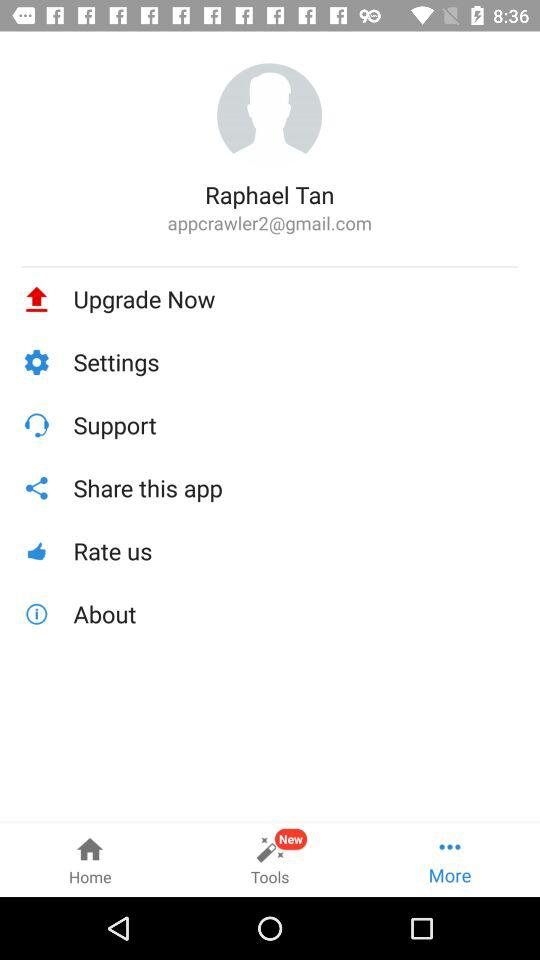How many tools are there?
When the provided information is insufficient, respond with <no answer>. <no answer> 